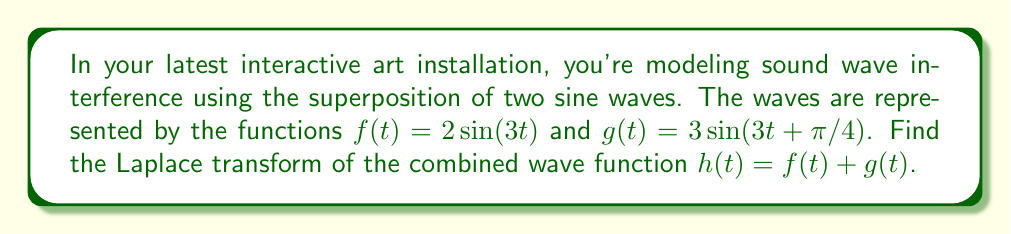Show me your answer to this math problem. To solve this problem, we'll follow these steps:

1) First, let's recall the Laplace transform of a sine function:
   $$\mathcal{L}\{\sin(at)\} = \frac{a}{s^2 + a^2}$$

2) For $f(t) = 2\sin(3t)$:
   $$\mathcal{L}\{f(t)\} = \mathcal{L}\{2\sin(3t)\} = 2 \cdot \frac{3}{s^2 + 3^2} = \frac{6}{s^2 + 9}$$

3) For $g(t) = 3\sin(3t+\pi/4)$, we need to use the time-shift property of Laplace transforms:
   $$\mathcal{L}\{g(t-a)\} = e^{-as}\mathcal{L}\{g(t)\}$$
   
   In our case, $a = -\pi/12$ (because $3t+\pi/4 = 3(t+\pi/12)$).

   So, $$\mathcal{L}\{g(t)\} = \mathcal{L}\{3\sin(3t+\pi/4)\} = 3e^{\pi s/12} \cdot \frac{3}{s^2 + 3^2} = \frac{9e^{\pi s/12}}{s^2 + 9}$$

4) Now, we can use the linearity property of Laplace transforms to find $\mathcal{L}\{h(t)\}$:
   $$\mathcal{L}\{h(t)\} = \mathcal{L}\{f(t) + g(t)\} = \mathcal{L}\{f(t)\} + \mathcal{L}\{g(t)\}$$

5) Substituting the results from steps 2 and 3:
   $$\mathcal{L}\{h(t)\} = \frac{6}{s^2 + 9} + \frac{9e^{\pi s/12}}{s^2 + 9}$$

6) Finding a common denominator:
   $$\mathcal{L}\{h(t)\} = \frac{6 + 9e^{\pi s/12}}{s^2 + 9}$$
Answer: $$\mathcal{L}\{h(t)\} = \frac{6 + 9e^{\pi s/12}}{s^2 + 9}$$ 